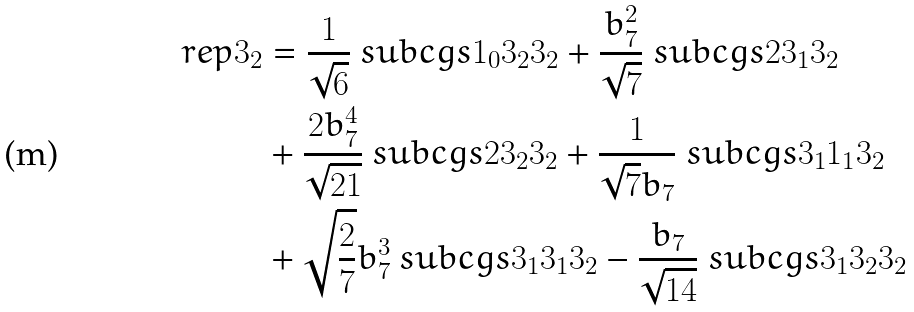Convert formula to latex. <formula><loc_0><loc_0><loc_500><loc_500>\ r e p { 3 } _ { 2 } & = \frac { 1 } { \sqrt { 6 } } \ s u b c g s { 1 _ { 0 } } { 3 _ { 2 } } { 3 _ { 2 } } + \frac { b _ { 7 } ^ { 2 } } { \sqrt { 7 } } \ s u b c g s { 2 } { 3 _ { 1 } } { 3 _ { 2 } } \\ & + \frac { 2 b _ { 7 } ^ { 4 } } { \sqrt { 2 1 } } \ s u b c g s { 2 } { 3 _ { 2 } } { 3 _ { 2 } } + \frac { 1 } { \sqrt { 7 } b _ { 7 } } \ s u b c g s { 3 _ { 1 } } { 1 _ { 1 } } { 3 _ { 2 } } \\ & + \sqrt { \frac { 2 } { 7 } } b _ { 7 } ^ { 3 } \ s u b c g s { 3 _ { 1 } } { 3 _ { 1 } } { 3 _ { 2 } } - \frac { b _ { 7 } } { \sqrt { 1 4 } } \ s u b c g s { 3 _ { 1 } } { 3 _ { 2 } } { 3 _ { 2 } }</formula> 